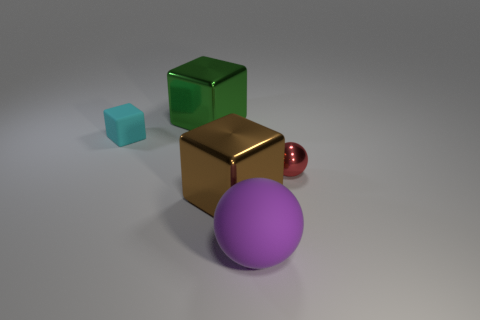Is there a green thing that has the same material as the tiny red object?
Make the answer very short. Yes. Are the tiny cyan block and the block in front of the small cyan object made of the same material?
Offer a terse response. No. The ball that is the same size as the cyan object is what color?
Your response must be concise. Red. There is a matte object in front of the rubber object that is on the left side of the purple rubber ball; what size is it?
Your response must be concise. Large. There is a tiny matte object; is its color the same as the cube that is to the right of the green shiny thing?
Your answer should be very brief. No. Are there fewer red shiny objects on the left side of the green shiny object than large green shiny cubes?
Make the answer very short. Yes. What number of other things are the same size as the brown metallic thing?
Ensure brevity in your answer.  2. Does the matte thing that is to the right of the tiny matte thing have the same shape as the brown object?
Provide a succinct answer. No. Is the number of big objects that are behind the big matte sphere greater than the number of blocks?
Give a very brief answer. No. The object that is both on the right side of the large brown shiny object and on the left side of the tiny sphere is made of what material?
Offer a very short reply. Rubber. 